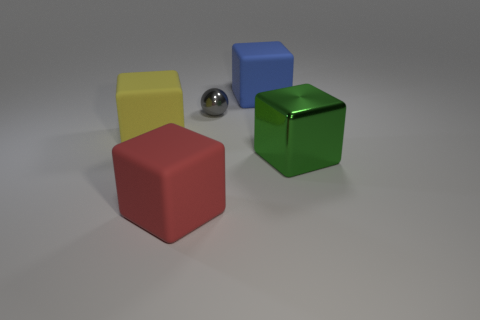Add 5 large yellow metal spheres. How many objects exist? 10 Subtract all cubes. How many objects are left? 1 Subtract 1 yellow cubes. How many objects are left? 4 Subtract all small things. Subtract all blue cubes. How many objects are left? 3 Add 5 large red rubber objects. How many large red rubber objects are left? 6 Add 3 small red matte spheres. How many small red matte spheres exist? 3 